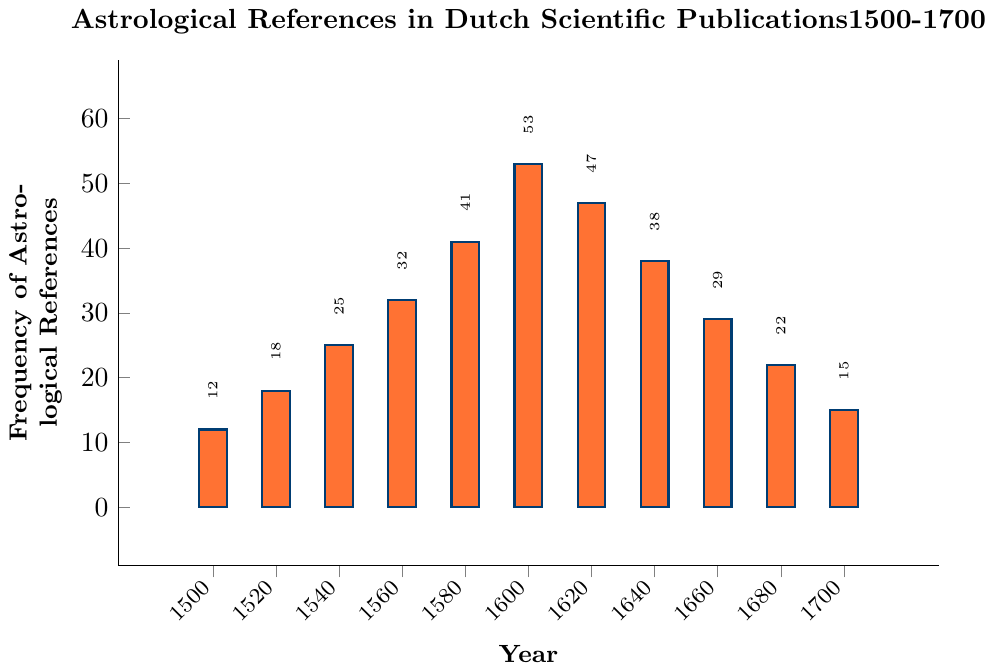What's the highest frequency of astrological references observed in the data? The highest point on the y-axis reached by any bar in the chart represents the highest frequency of astrological references.
Answer: 53 When was the highest frequency of astrological references observed? The tallest bar in the chart, which indicates the highest frequency of references, is associated with the year 1600.
Answer: 1600 What is the difference in the frequency of astrological references between the years 1600 and 1700? Subtract the frequency in 1700 (15) from the frequency in 1600 (53).
Answer: 38 How does the frequency in 1560 compare to that in 1640? Comparing the bar heights: The frequency in 1560 is 32, and in 1640 it is 38. 38 is greater than 32.
Answer: 1640 is higher What is the average frequency of astrological references over the century (1600-1700)? Sum the frequencies for years 1600, 1620, 1640, 1660, 1680, and 1700 and then divide by 6: (53 + 47 + 38 + 29 + 22 + 15) / 6 = 204 / 6.
Answer: 34 Which year shows a decrease in astrological references from the previous recorded year, and by how much? Comparing years, instances where the current year's frequency is less than the previous: from 1600 to 1620 there is a decrease (53 to 47, 53-47). First year is 1600 and next year shows decrease is 1620.
Answer: 6 How many years show a higher frequency than 30 astrological references? Count the bars extending above the 30-marks on the y-axis: (1560, 1580, 1600, 1620, 1640).
Answer: 5 years What was the percentage increase in astrological references from 1580 to 1600? Calculate the percentage increase: (53 - 41) / 41 * 100%.
Answer: ~29.27% What is the median frequency of astrological references for all recorded years? Arrange frequencies in ascending order and find the middle value(s): Median of {12, 15, 18, 22, 25, 29, 32, 38, 41, 47, 53} is the average of the 6th and 7th values, (29+32) / 2.
Answer: 30.5 Which decade shows the lowest frequency of astrological references? Locate the bar with the smallest height and note the corresponding year: 1500 has the smallest frequency (12).
Answer: 1500 